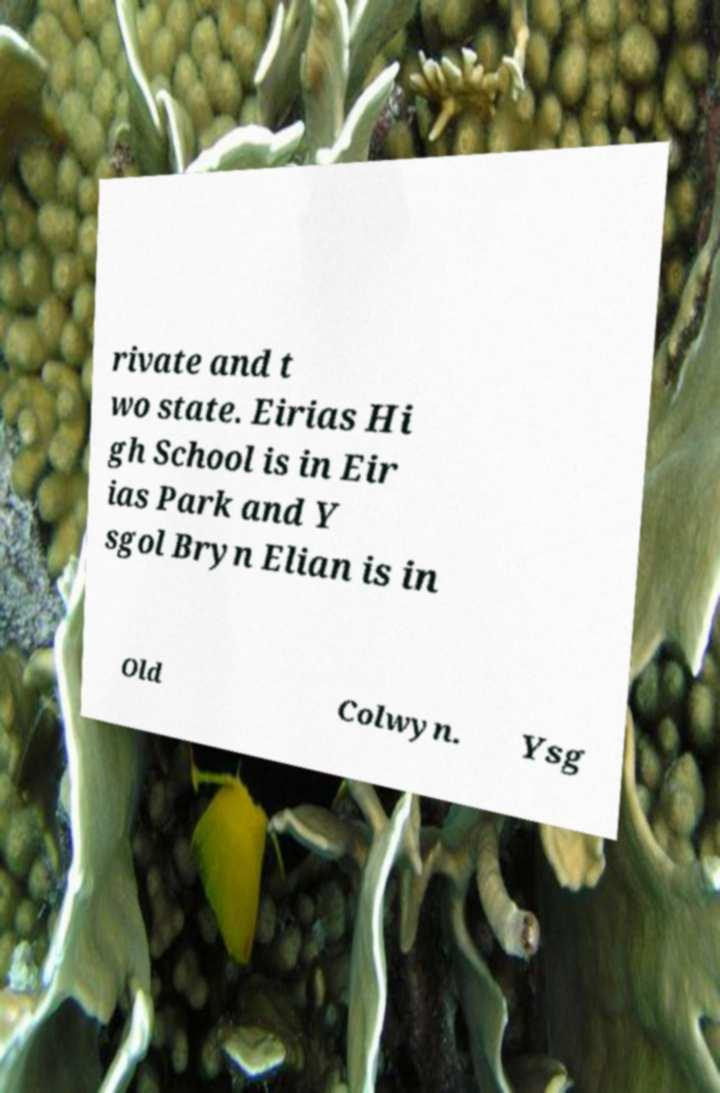Can you accurately transcribe the text from the provided image for me? rivate and t wo state. Eirias Hi gh School is in Eir ias Park and Y sgol Bryn Elian is in Old Colwyn. Ysg 